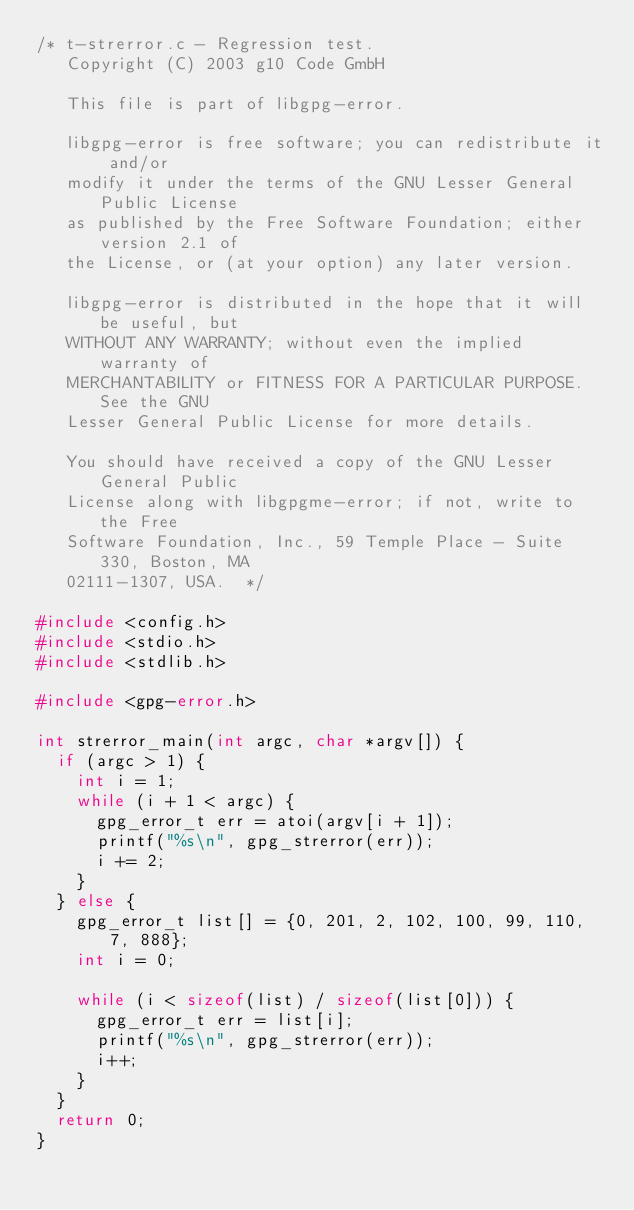Convert code to text. <code><loc_0><loc_0><loc_500><loc_500><_C++_>/* t-strerror.c - Regression test.
   Copyright (C) 2003 g10 Code GmbH

   This file is part of libgpg-error.

   libgpg-error is free software; you can redistribute it and/or
   modify it under the terms of the GNU Lesser General Public License
   as published by the Free Software Foundation; either version 2.1 of
   the License, or (at your option) any later version.

   libgpg-error is distributed in the hope that it will be useful, but
   WITHOUT ANY WARRANTY; without even the implied warranty of
   MERCHANTABILITY or FITNESS FOR A PARTICULAR PURPOSE.  See the GNU
   Lesser General Public License for more details.

   You should have received a copy of the GNU Lesser General Public
   License along with libgpgme-error; if not, write to the Free
   Software Foundation, Inc., 59 Temple Place - Suite 330, Boston, MA
   02111-1307, USA.  */

#include <config.h>
#include <stdio.h>
#include <stdlib.h>

#include <gpg-error.h>

int strerror_main(int argc, char *argv[]) {
  if (argc > 1) {
    int i = 1;
    while (i + 1 < argc) {
      gpg_error_t err = atoi(argv[i + 1]);
      printf("%s\n", gpg_strerror(err));
      i += 2;
    }
  } else {
    gpg_error_t list[] = {0, 201, 2, 102, 100, 99, 110, 7, 888};
    int i = 0;

    while (i < sizeof(list) / sizeof(list[0])) {
      gpg_error_t err = list[i];
      printf("%s\n", gpg_strerror(err));
      i++;
    }
  }
  return 0;
}
</code> 